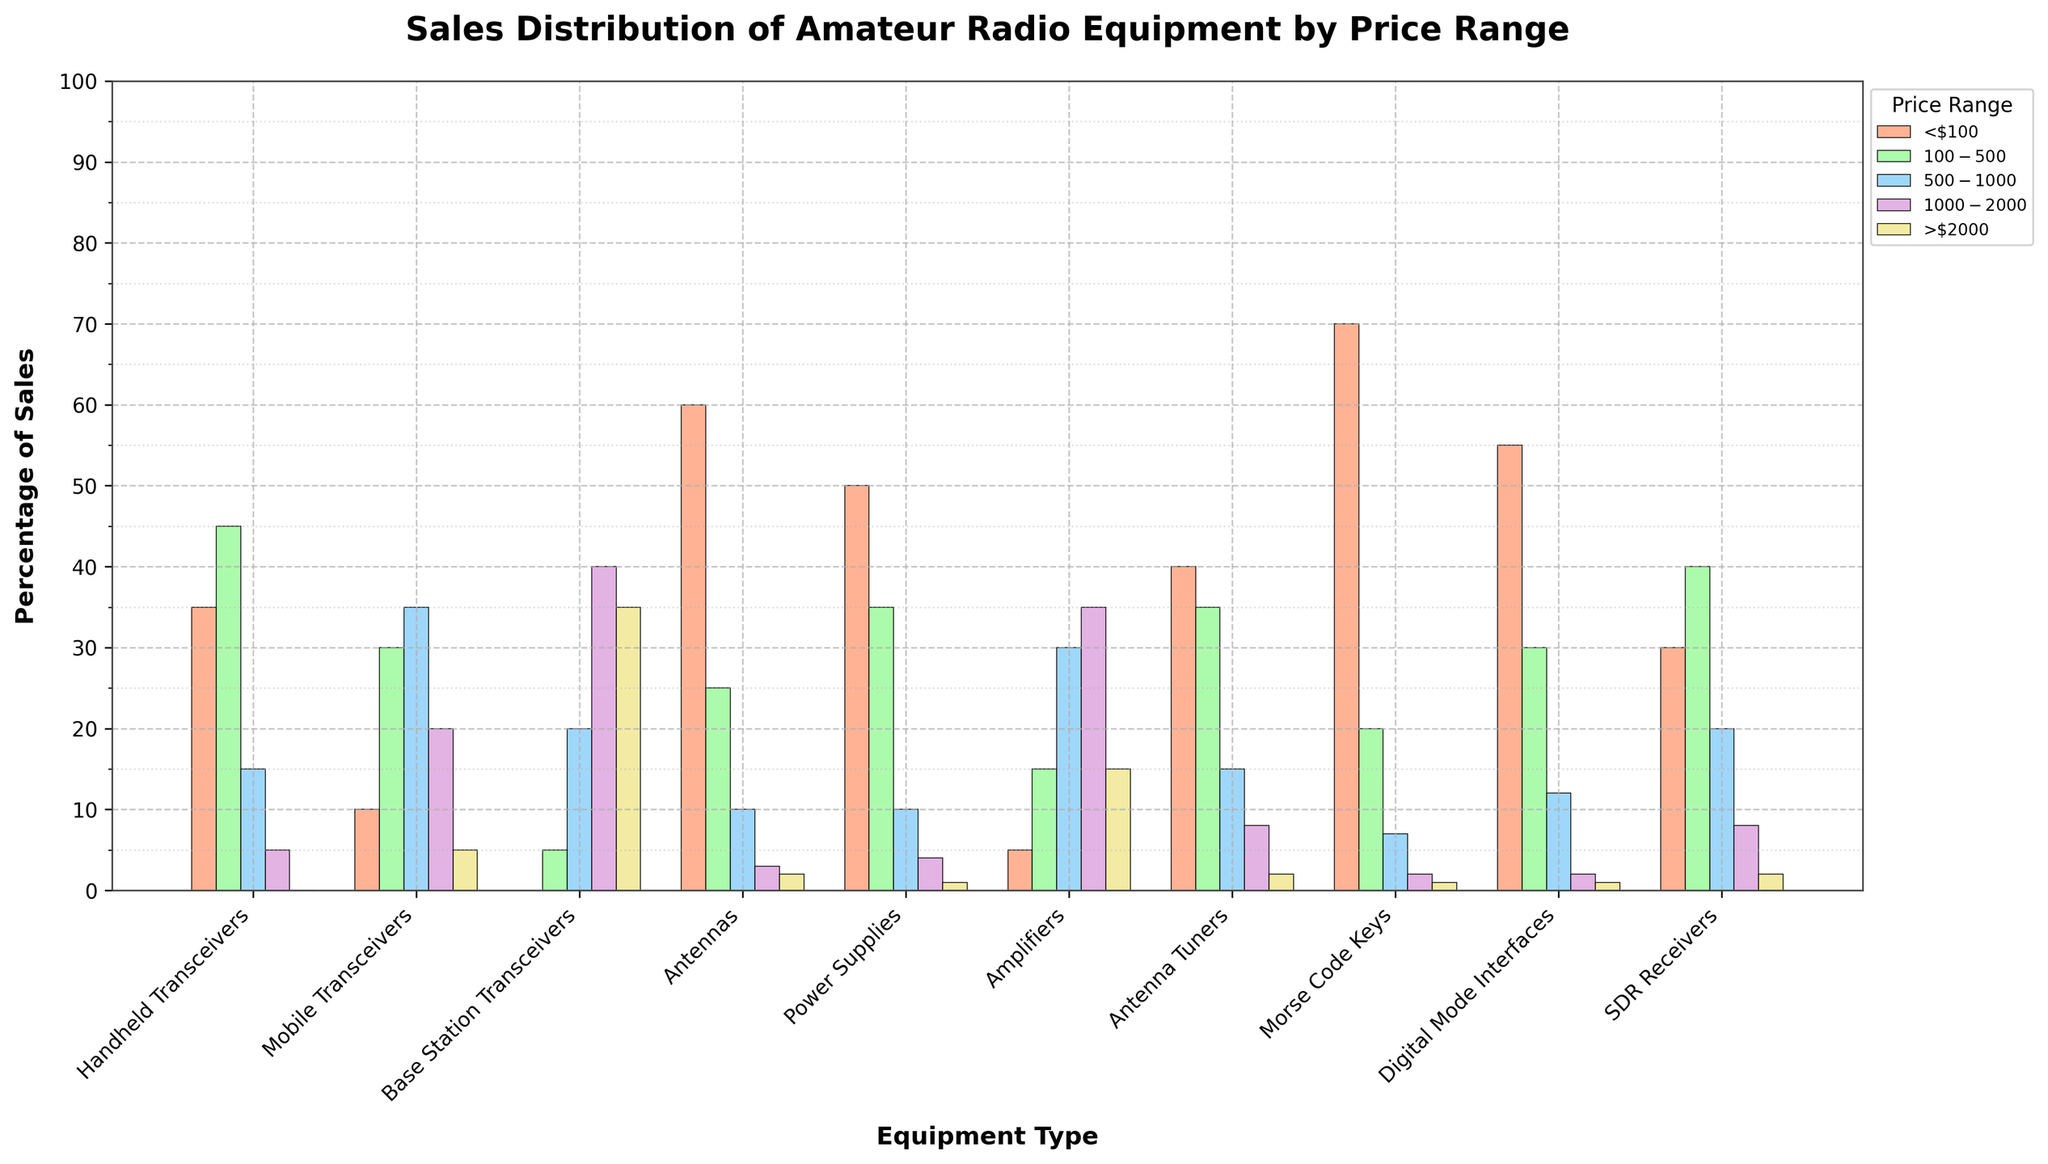Which equipment type has the highest sales in the <$100 price range? To identify the equipment type with the highest sales in the <$100 price range, look at the first column of bars and find the tallest one. The tallest bar in this column is for Morse Code Keys, indicating that they have the highest sales in this price range.
Answer: Morse Code Keys What is the total percentage of sales for Base Station Transceivers in the $500-$1000 and $1000-$2000 price ranges combined? To find the total percentage of sales for Base Station Transceivers in the $500-$1000 and $1000-$2000 price ranges combined, sum the values in these two price ranges. According to the chart, Base Station Transceivers have 20% sales in the $500-$1000 range and 40% in the $1000-$2000 range. Hence, the total is 20% + 40% = 60%.
Answer: 60% Which price range has the least sales for Handheld Transceivers? Look at the different columns for Handheld Transceivers and identify the shortest bar. The shortest bar for Handheld Transceivers is in the >$2000 price range, with 0% sales.
Answer: >$2000 How do the sales of Mobile Transceivers in the $100-$500 price range compare to Mobile Transceivers in the $500-$1000 price range? To compare, find the bars representing Mobile Transceivers in the $100-$500 price range and $500-$1000 price range. The bar for $100-$500 is shorter than the bar for $500-$1000, indicating fewer sales. Specifically, Mobile Transceivers have 30% in the $100-$500 range and 35% in the $500-$1000 range.
Answer: $100-$500 is less Which two equipment types have the highest sales in the >$2000 price range? To identify the two equipment types with the highest sales in the >$2000 price range, find the two tallest bars in this column. The tallest bar is for Base Station Transceivers (35%) followed by Amplifiers (15%).
Answer: Base Station Transceivers, Amplifiers What's the difference in sales percentage between Antennas and Power Supplies in the $100-$500 price range? First, find the sales percentages for Antennas and Power Supplies in the $100-$500 price range: Antennas have 25% and Power Supplies have 35%. Then, calculate the difference: 35% - 25% = 10%.
Answer: 10% How do the sales percentages for SDR Receivers in the <$100 and $100-$500 price ranges add up? To find how the sales percentages for SDR Receivers in the <$100 and $100-$500 price ranges add up, sum their values in these ranges. For SDR Receivers, the sales are 30% in <$100 and 40% in $100-$500. So, 30% + 40% = 70%.
Answer: 70% Which equipment type has the most evenly distributed sales across all price ranges? To determine the equipment type with the most evenly distributed sales, look for the one with bars of relatively similar heights in all price ranges. Digital Mode Interfaces have percentages of 55, 30, 12, 2, and 1 across the respective price ranges, indicating a more even distribution compared to other equipment types.
Answer: Digital Mode Interfaces What is the combined percentage of sales for Morse Code Keys in the <$100 and $100-$500 price ranges? To find the combined percentage of sales for Morse Code Keys in the <$100 and $100-$500 price ranges, sum the values in these price ranges. Morse Code Keys have 70% sales in <$100 and 20% in $100-$500. Therefore, the total is 70% + 20% = 90%.
Answer: 90% Which equipment type shows the highest sales percentage in the $500-$1000 price range? Look at the column denoting $500-$1000 price range and identify the tallest bar. The tallest bar is for Mobile Transceivers with 35%.
Answer: Mobile Transceivers 